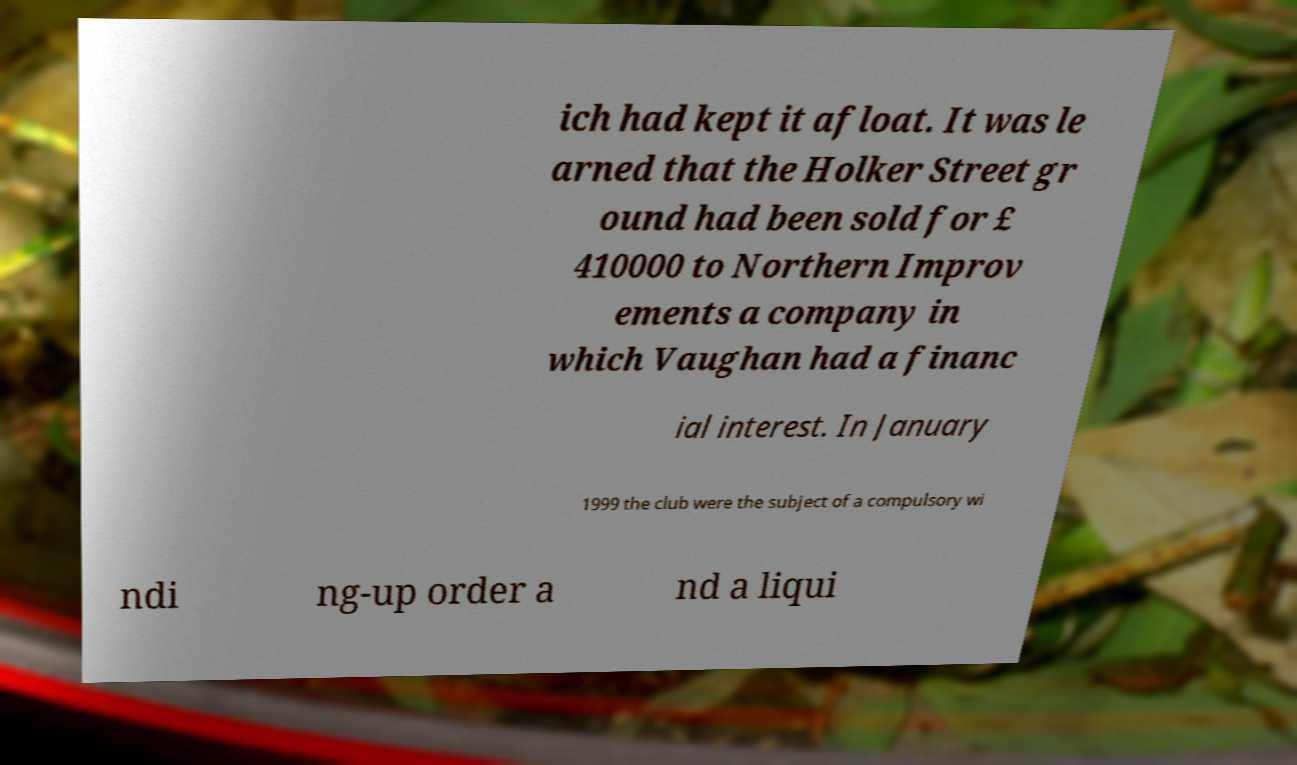Can you read and provide the text displayed in the image?This photo seems to have some interesting text. Can you extract and type it out for me? ich had kept it afloat. It was le arned that the Holker Street gr ound had been sold for £ 410000 to Northern Improv ements a company in which Vaughan had a financ ial interest. In January 1999 the club were the subject of a compulsory wi ndi ng-up order a nd a liqui 